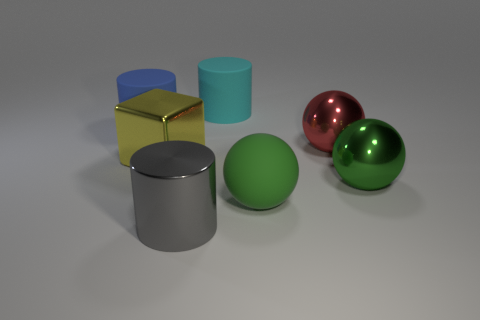Subtract all blue cubes. How many green spheres are left? 2 Subtract all big metallic spheres. How many spheres are left? 1 Add 1 large matte things. How many objects exist? 8 Subtract 1 cylinders. How many cylinders are left? 2 Subtract all balls. How many objects are left? 4 Subtract 0 gray cubes. How many objects are left? 7 Subtract all red spheres. Subtract all yellow cylinders. How many spheres are left? 2 Subtract all small blue rubber cylinders. Subtract all gray metallic cylinders. How many objects are left? 6 Add 3 big matte cylinders. How many big matte cylinders are left? 5 Add 2 small red cubes. How many small red cubes exist? 2 